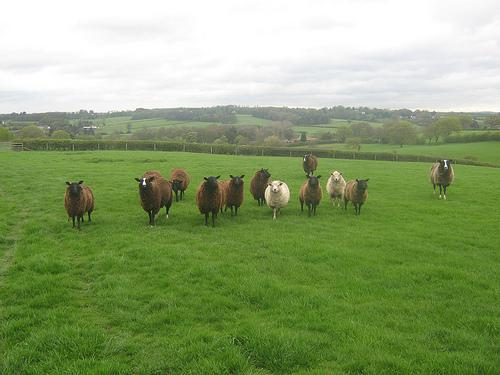Question: where was the photo taken?
Choices:
A. In a pasture.
B. At a barnyard.
C. At a zoo.
D. In the mountains.
Answer with the letter. Answer: A Question: who takes care of the sheep?
Choices:
A. A man.
B. A boy.
C. A shepherd.
D. Two boys.
Answer with the letter. Answer: C Question: what is the weather like?
Choices:
A. Sunny.
B. Cold.
C. Cloudy.
D. Windy.
Answer with the letter. Answer: C Question: how many white sheep are there?
Choices:
A. Two.
B. Four.
C. One.
D. Eleven.
Answer with the letter. Answer: A 